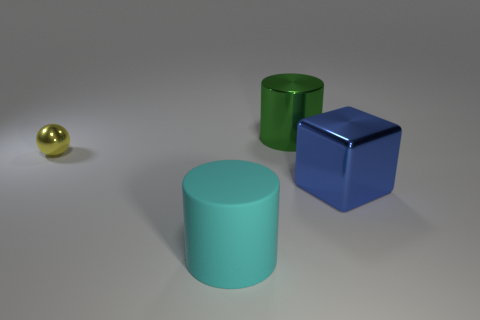Add 3 tiny gray rubber things. How many objects exist? 7 Subtract all balls. How many objects are left? 3 Add 1 small shiny objects. How many small shiny objects exist? 2 Subtract 0 red cylinders. How many objects are left? 4 Subtract all small red shiny cylinders. Subtract all blue metal objects. How many objects are left? 3 Add 2 metallic objects. How many metallic objects are left? 5 